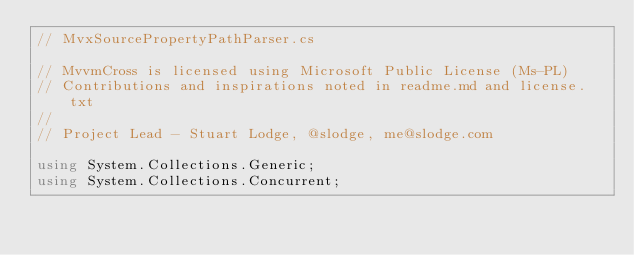<code> <loc_0><loc_0><loc_500><loc_500><_C#_>// MvxSourcePropertyPathParser.cs

// MvvmCross is licensed using Microsoft Public License (Ms-PL)
// Contributions and inspirations noted in readme.md and license.txt
//
// Project Lead - Stuart Lodge, @slodge, me@slodge.com

using System.Collections.Generic;
using System.Collections.Concurrent;</code> 